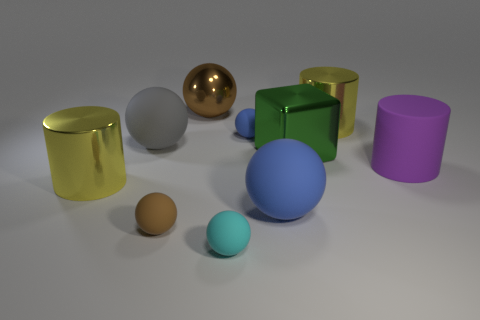How many objects are either big balls that are behind the gray thing or large yellow cylinders that are on the left side of the large gray sphere?
Give a very brief answer. 2. Are there more yellow shiny cylinders behind the large rubber cylinder than large green cubes?
Offer a very short reply. No. What number of other things are the same shape as the small cyan matte object?
Offer a very short reply. 5. There is a large cylinder that is both left of the rubber cylinder and on the right side of the cyan thing; what is its material?
Provide a succinct answer. Metal. How many things are either yellow things or large green balls?
Offer a very short reply. 2. Are there more purple metallic spheres than purple objects?
Your response must be concise. No. There is a blue sphere that is behind the yellow metal object that is in front of the purple cylinder; what size is it?
Provide a short and direct response. Small. What is the color of the other big metal thing that is the same shape as the large blue object?
Provide a succinct answer. Brown. What is the size of the green metallic block?
Your answer should be very brief. Large. What number of spheres are either blue matte things or tiny cyan rubber things?
Give a very brief answer. 3. 